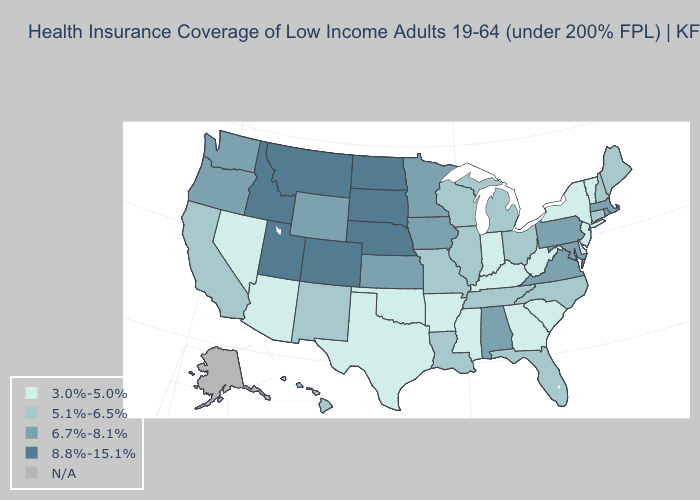Does Mississippi have the lowest value in the USA?
Keep it brief. Yes. Does the map have missing data?
Be succinct. Yes. Does the map have missing data?
Give a very brief answer. Yes. Which states hav the highest value in the MidWest?
Give a very brief answer. Nebraska, North Dakota, South Dakota. Does New Jersey have the lowest value in the Northeast?
Write a very short answer. Yes. Is the legend a continuous bar?
Keep it brief. No. Which states hav the highest value in the MidWest?
Write a very short answer. Nebraska, North Dakota, South Dakota. Does New Jersey have the lowest value in the USA?
Keep it brief. Yes. Which states hav the highest value in the West?
Answer briefly. Colorado, Idaho, Montana, Utah. Does Indiana have the lowest value in the MidWest?
Keep it brief. Yes. Name the states that have a value in the range 8.8%-15.1%?
Be succinct. Colorado, Idaho, Montana, Nebraska, North Dakota, South Dakota, Utah. What is the value of Michigan?
Keep it brief. 5.1%-6.5%. What is the value of Iowa?
Keep it brief. 6.7%-8.1%. What is the value of New Mexico?
Keep it brief. 5.1%-6.5%. What is the lowest value in the USA?
Quick response, please. 3.0%-5.0%. 